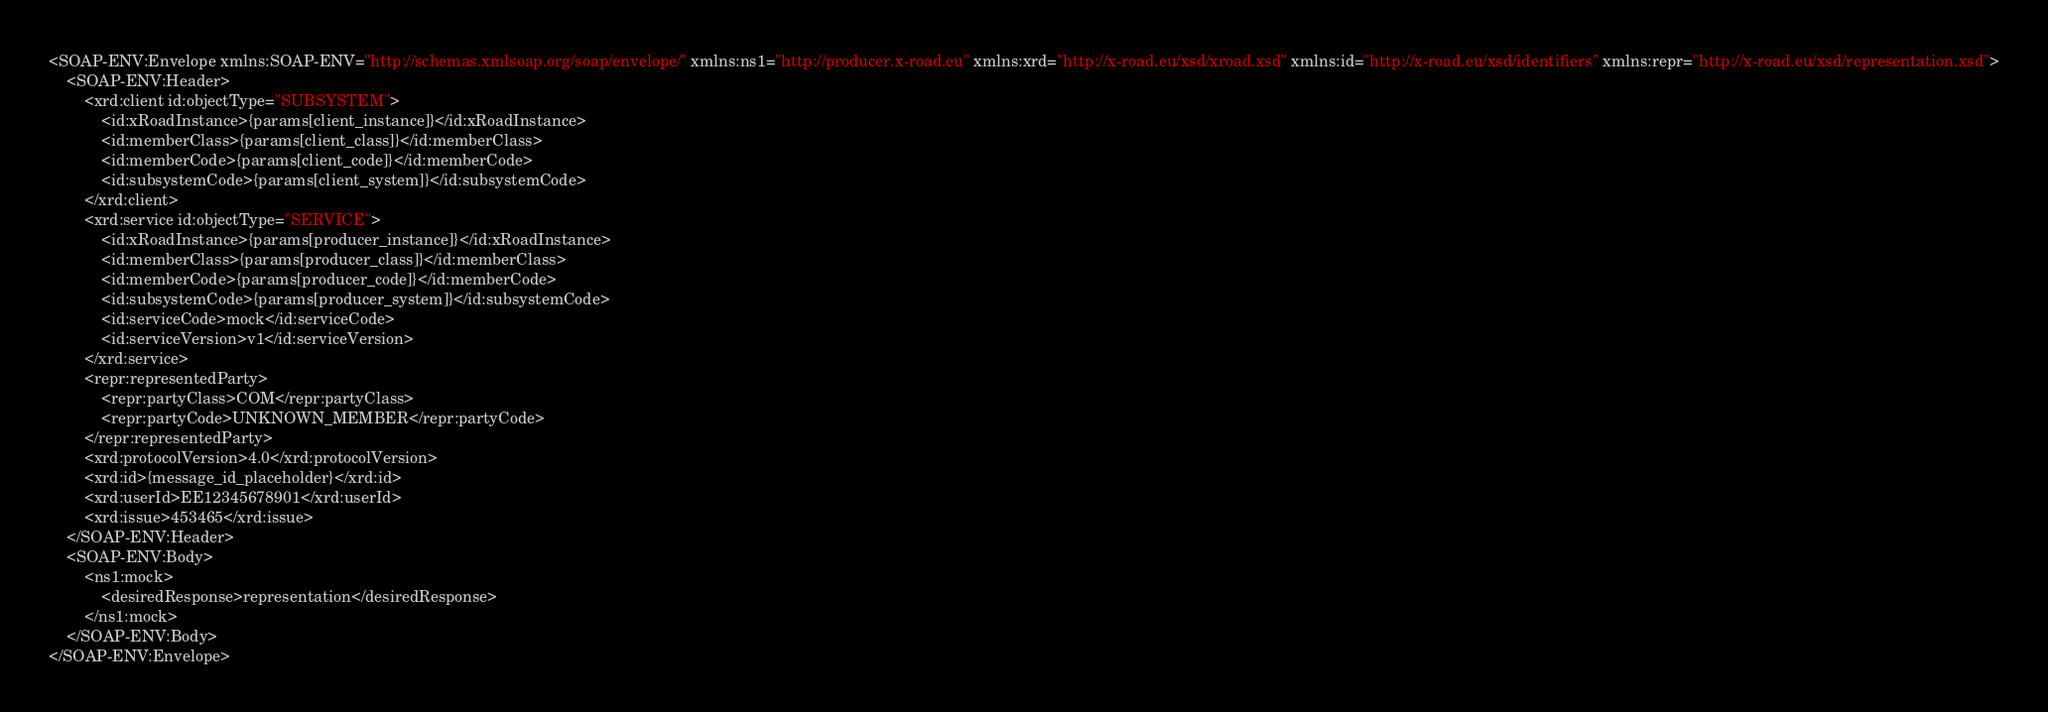<code> <loc_0><loc_0><loc_500><loc_500><_XML_><SOAP-ENV:Envelope xmlns:SOAP-ENV="http://schemas.xmlsoap.org/soap/envelope/" xmlns:ns1="http://producer.x-road.eu" xmlns:xrd="http://x-road.eu/xsd/xroad.xsd" xmlns:id="http://x-road.eu/xsd/identifiers" xmlns:repr="http://x-road.eu/xsd/representation.xsd">
    <SOAP-ENV:Header>
        <xrd:client id:objectType="SUBSYSTEM">
            <id:xRoadInstance>{params[client_instance]}</id:xRoadInstance>
            <id:memberClass>{params[client_class]}</id:memberClass>
            <id:memberCode>{params[client_code]}</id:memberCode>
            <id:subsystemCode>{params[client_system]}</id:subsystemCode>
        </xrd:client>
        <xrd:service id:objectType="SERVICE">
            <id:xRoadInstance>{params[producer_instance]}</id:xRoadInstance>
            <id:memberClass>{params[producer_class]}</id:memberClass>
            <id:memberCode>{params[producer_code]}</id:memberCode>
            <id:subsystemCode>{params[producer_system]}</id:subsystemCode>
            <id:serviceCode>mock</id:serviceCode>
            <id:serviceVersion>v1</id:serviceVersion>
        </xrd:service>
        <repr:representedParty>
            <repr:partyClass>COM</repr:partyClass>
            <repr:partyCode>UNKNOWN_MEMBER</repr:partyCode>
        </repr:representedParty>
        <xrd:protocolVersion>4.0</xrd:protocolVersion>
        <xrd:id>{message_id_placeholder}</xrd:id>
        <xrd:userId>EE12345678901</xrd:userId>
        <xrd:issue>453465</xrd:issue>
    </SOAP-ENV:Header>
    <SOAP-ENV:Body>
        <ns1:mock>
            <desiredResponse>representation</desiredResponse>
        </ns1:mock>
    </SOAP-ENV:Body>
</SOAP-ENV:Envelope>
</code> 